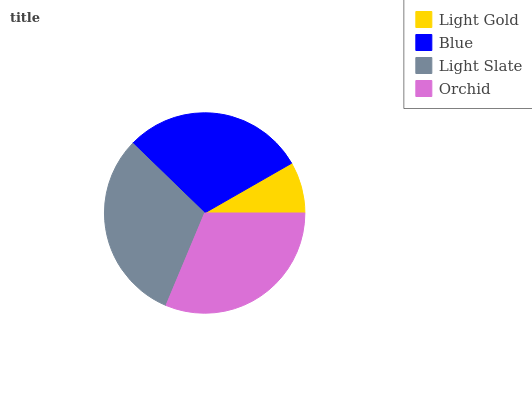Is Light Gold the minimum?
Answer yes or no. Yes. Is Orchid the maximum?
Answer yes or no. Yes. Is Blue the minimum?
Answer yes or no. No. Is Blue the maximum?
Answer yes or no. No. Is Blue greater than Light Gold?
Answer yes or no. Yes. Is Light Gold less than Blue?
Answer yes or no. Yes. Is Light Gold greater than Blue?
Answer yes or no. No. Is Blue less than Light Gold?
Answer yes or no. No. Is Light Slate the high median?
Answer yes or no. Yes. Is Blue the low median?
Answer yes or no. Yes. Is Orchid the high median?
Answer yes or no. No. Is Light Slate the low median?
Answer yes or no. No. 